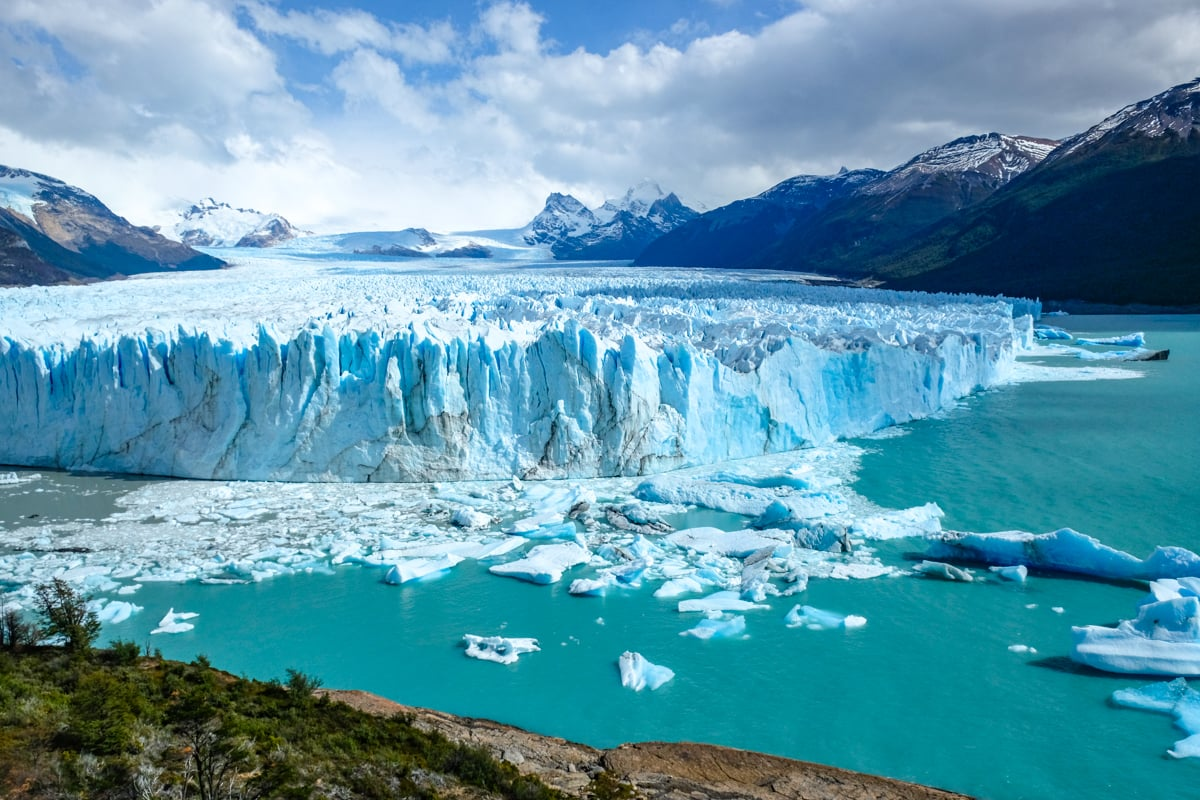What kind of wildlife might one see in the vicinity of this glacier? The region surrounding Perito Moreno Glacier is a habitat for a variety of wildlife, particularly birds like the Andean condor, Magellanic woodpecker, and the black-chested buzzard eagle. In the nearby waters, one may spot several species endemic to Patagonia, such as the Andean duck and the crested cara cara. Mammals are less visible but include the guanaco, a camelid related to the llama, and pumas which roam the more secluded areas of the park. Visitors can often see these animals while exploring the trails and viewing platforms around the glacier. 